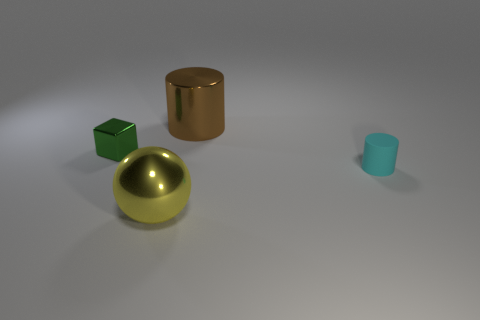There is a small thing on the right side of the large brown cylinder; is there a tiny shiny thing that is in front of it?
Ensure brevity in your answer.  No. Is the material of the big object behind the shiny cube the same as the green cube?
Provide a short and direct response. Yes. How many other things are the same color as the shiny cylinder?
Keep it short and to the point. 0. Does the matte object have the same color as the tiny metal block?
Provide a short and direct response. No. There is a shiny thing to the right of the large metal object in front of the small cyan cylinder; what size is it?
Provide a succinct answer. Large. Is the brown thing to the left of the tiny cyan rubber thing made of the same material as the tiny object that is in front of the green metallic object?
Give a very brief answer. No. There is a big shiny object behind the small green metal thing; is its color the same as the metallic cube?
Offer a very short reply. No. There is a large metal cylinder; how many small cyan rubber cylinders are in front of it?
Make the answer very short. 1. Are the tiny cyan cylinder and the tiny thing behind the small cyan matte object made of the same material?
Your response must be concise. No. What size is the ball that is made of the same material as the big cylinder?
Ensure brevity in your answer.  Large. 